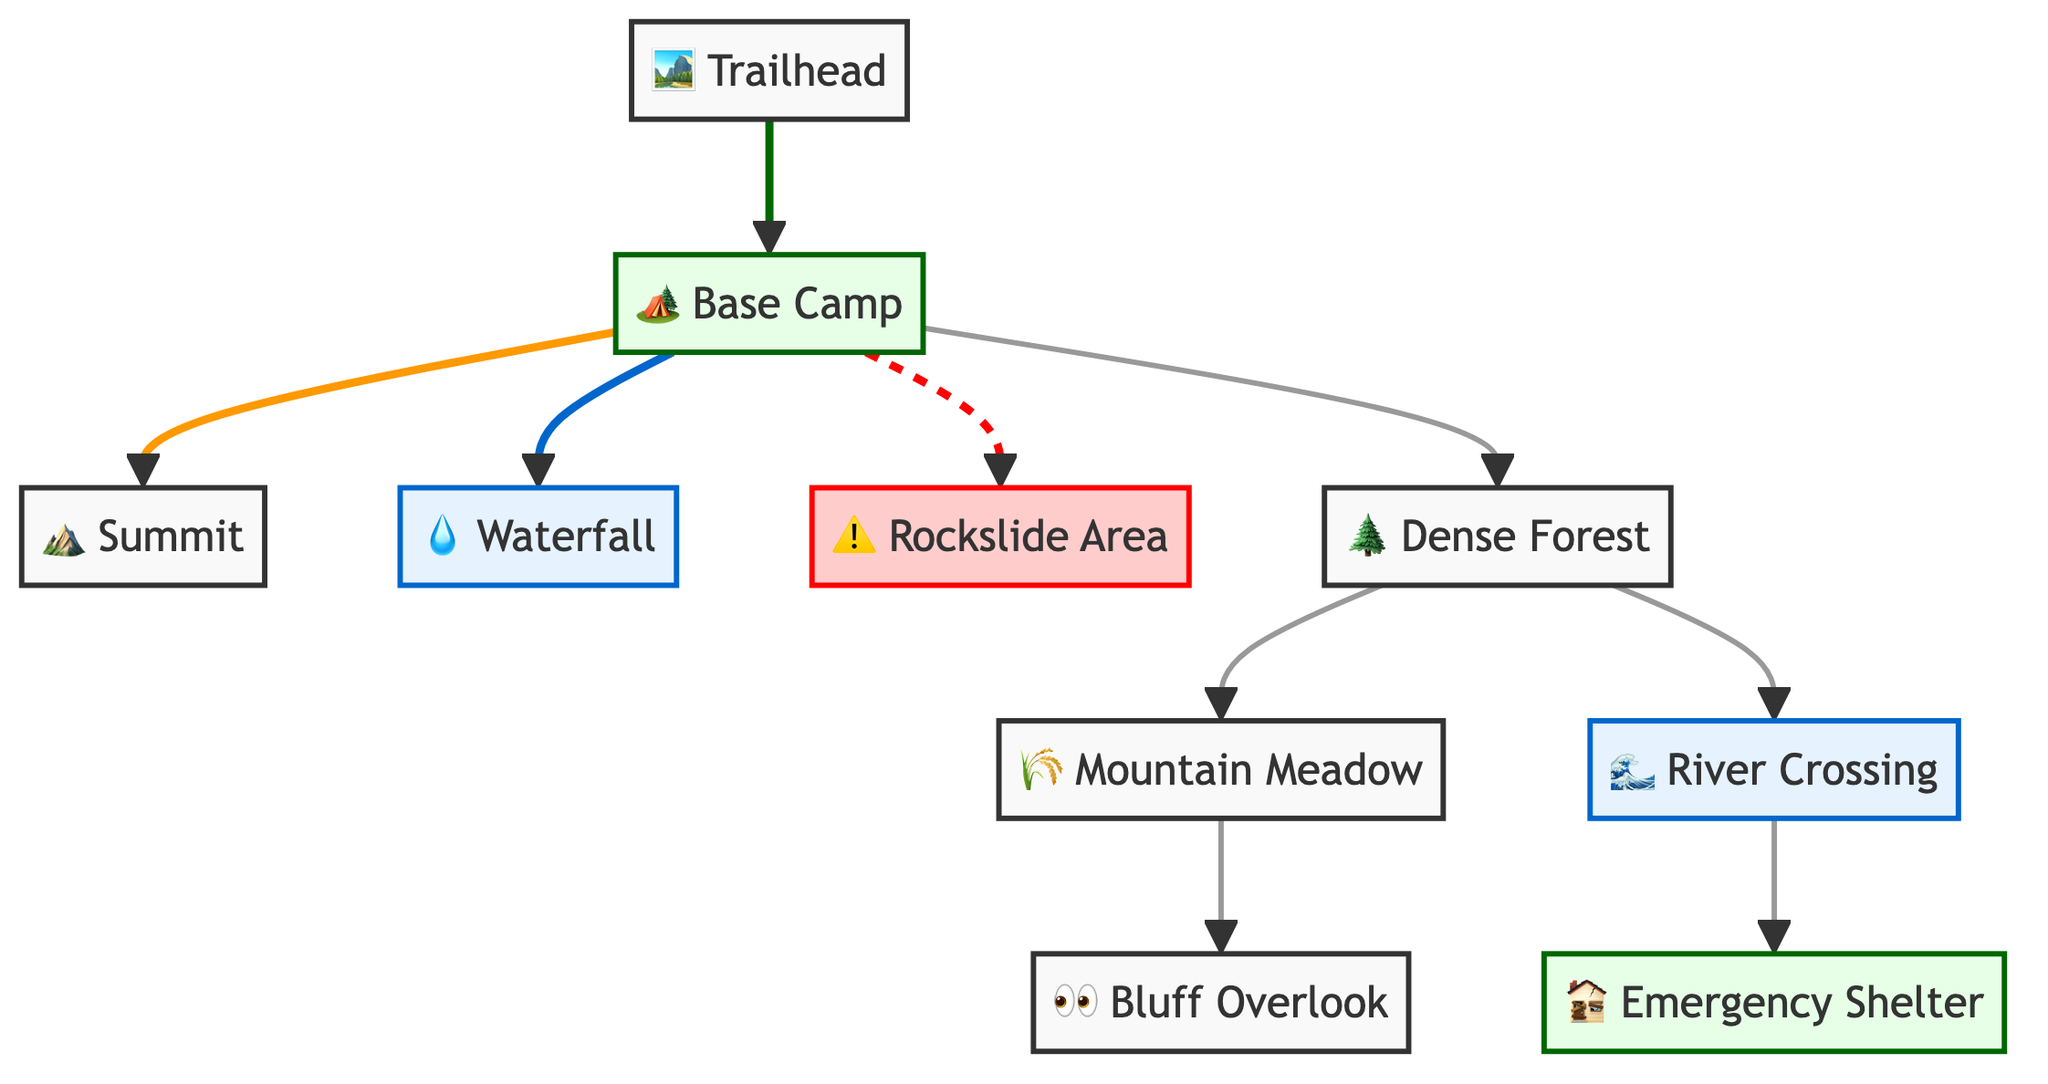What is the starting point of the trail? The starting point of the trail is indicated by the node labeled "Trailhead". This can be identified as the first node in the diagram, represented by "1".
Answer: Trailhead How many essential landmarks are connected to Base Camp? Base Camp is connected to four essential landmarks: Summit, Waterfall, Rockslide Area, and Dense Forest. Counting these nodes that flow from Base Camp gives us a total of four.
Answer: 4 What is the danger zone labeled in the diagram? The danger zone is labeled as "Rockslide Area". In the diagram, it is visually represented with a warning symbol (⚠️) and is recognized as a hazardous area.
Answer: Rockslide Area Which landmark is a water source? The landmark serving as a water source is the "Waterfall". This is explicitly shown with the water symbol (💧), indicating it is a source of water in the terrain.
Answer: Waterfall If someone is at the Mountain Meadow, what two routes can they take next? From the Mountain Meadow, one can either go to the Bluff Overlook or backtrack to the Dense Forest. The connections from the Mountain Meadow in the diagram show these as possible routes to follow.
Answer: Bluff Overlook and Dense Forest How many total nodes (locations) are included in the diagram? To find the total nodes, we count each unique location in the diagram: Trailhead, Base Camp, Summit, Waterfall, Bluff Overlook, Rockslide Area, Dense Forest, River Crossing, Mountain Meadow, and Emergency Shelter. This gives us a total of ten nodes.
Answer: 10 What type of area is Emergency Shelter categorized as? The Emergency Shelter is categorized as a shelter area, indicated in the diagram. It is visually represented using the shelter color fill and labeled as "Emergency Shelter".
Answer: Shelter Which two areas are connected via the River Crossing? The River Crossing connects the Dense Forest and the Emergency Shelter. In the diagram, this is shown as a direct link between these two nodes.
Answer: Dense Forest and Emergency Shelter What is the first destination after the Trailhead? The first destination after the Trailhead is the Base Camp. This is the immediate connection that follows the Trailhead in the diagram.
Answer: Base Camp 